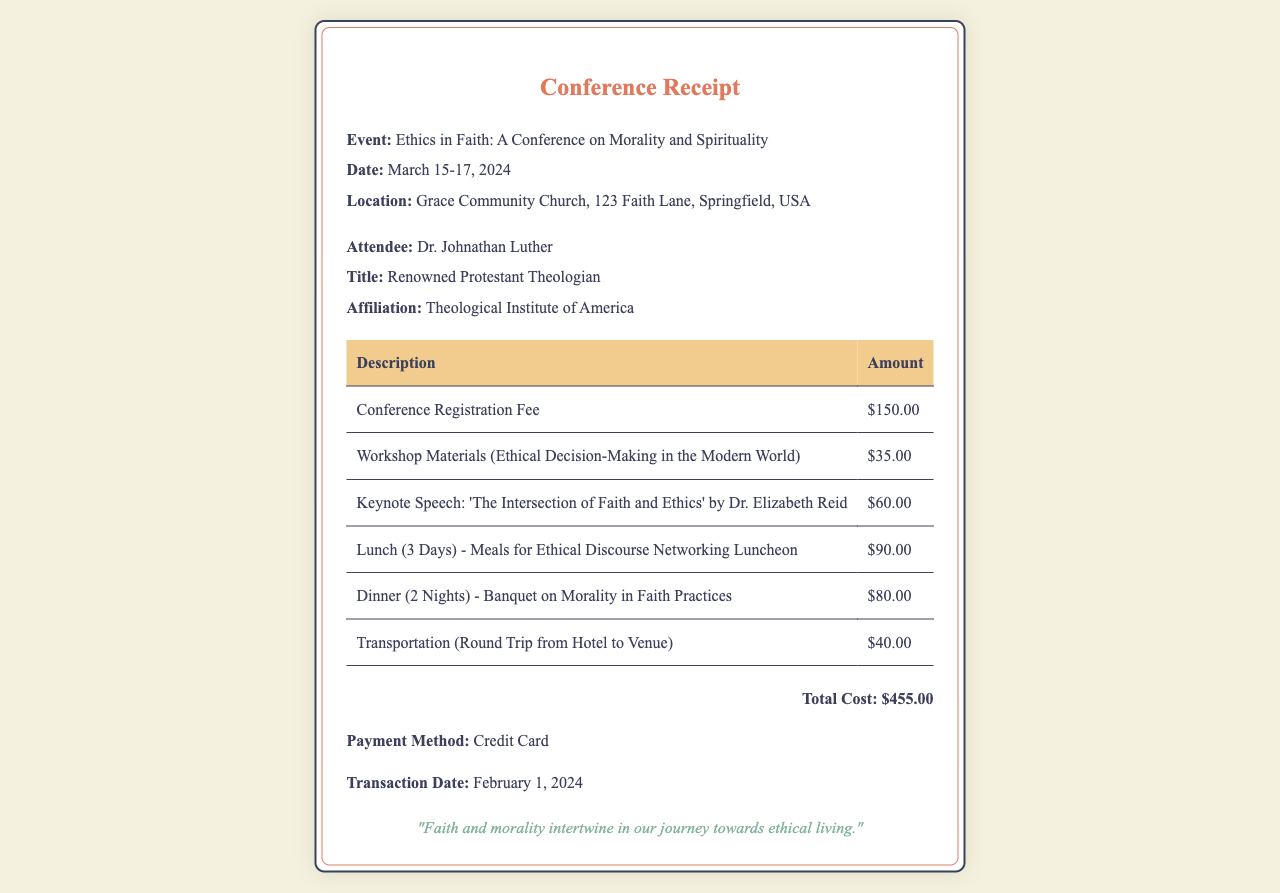What is the event's theme? The event's theme, derived from its title, focuses on morality and spirituality; it emphasizes ethical conversations in a faith context.
Answer: Ethics in Faith: A Conference on Morality and Spirituality What is the total cost of attendance? The total cost is derived by summing all individual costs listed in the receipt.
Answer: $455.00 Who is the keynote speaker? The name of the keynote speaker is mentioned under the keynote speech section in the document.
Answer: Dr. Elizabeth Reid How many meals are included in the registration? The meals include lunches for three days and dinners for two nights, totaling five meals.
Answer: 5 What payment method was used? The specific payment method is indicated in the receipt.
Answer: Credit Card What is the date range of the conference? The date is explicitly stated in a section of the document, providing the start and end dates.
Answer: March 15-17, 2024 What was the cost for workshop materials? The cost is specified in the itemized list of expenses in the receipt.
Answer: $35.00 How many nights of dinner are included? The number of dinner nights is stated in the document and focuses on the total provided for the event.
Answer: 2 What is the location of the conference? The conference location is clearly laid out as part of the event information in the document.
Answer: Grace Community Church, 123 Faith Lane, Springfield, USA 